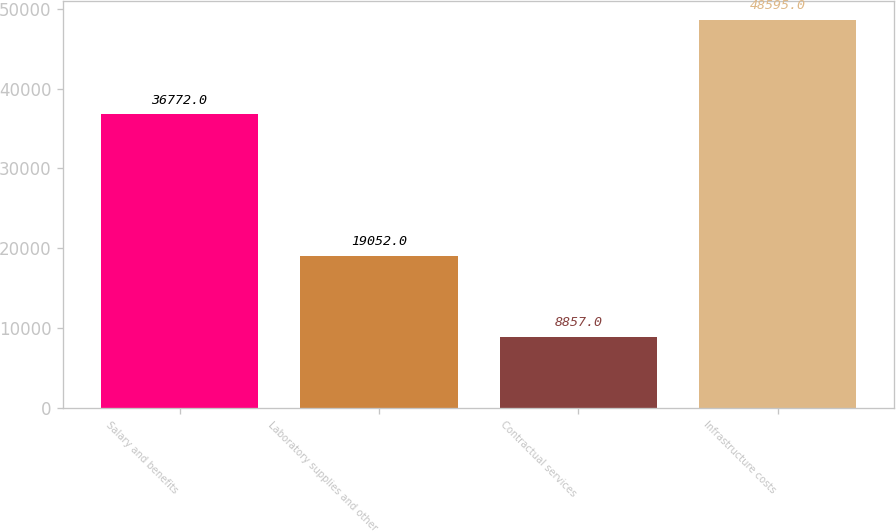<chart> <loc_0><loc_0><loc_500><loc_500><bar_chart><fcel>Salary and benefits<fcel>Laboratory supplies and other<fcel>Contractual services<fcel>Infrastructure costs<nl><fcel>36772<fcel>19052<fcel>8857<fcel>48595<nl></chart> 